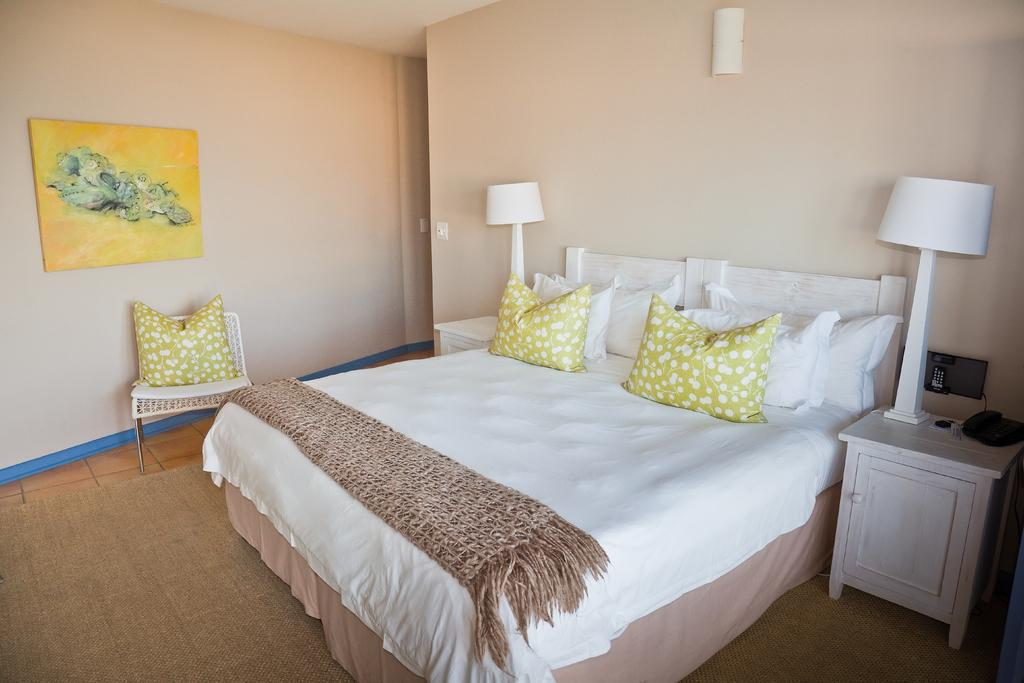What type of furniture is present in the image? There is a bed, a chair, and cupboards in the image. What items are on the bed? There are pillows on the bed. What type of lighting is present in the image? There are lamps in the image. What type of communication device is present in the image? There is a telephone in the image. What type of personal items are present in the image? There are clothes in the image. What can be seen in the background of the image? There is a wall and a frame in the background of the image. How many eggs are visible on the bed in the image? There are no eggs visible on the bed in the image. What type of field is present in the image? There is no field present in the image; it is an indoor setting with furniture and personal items. 